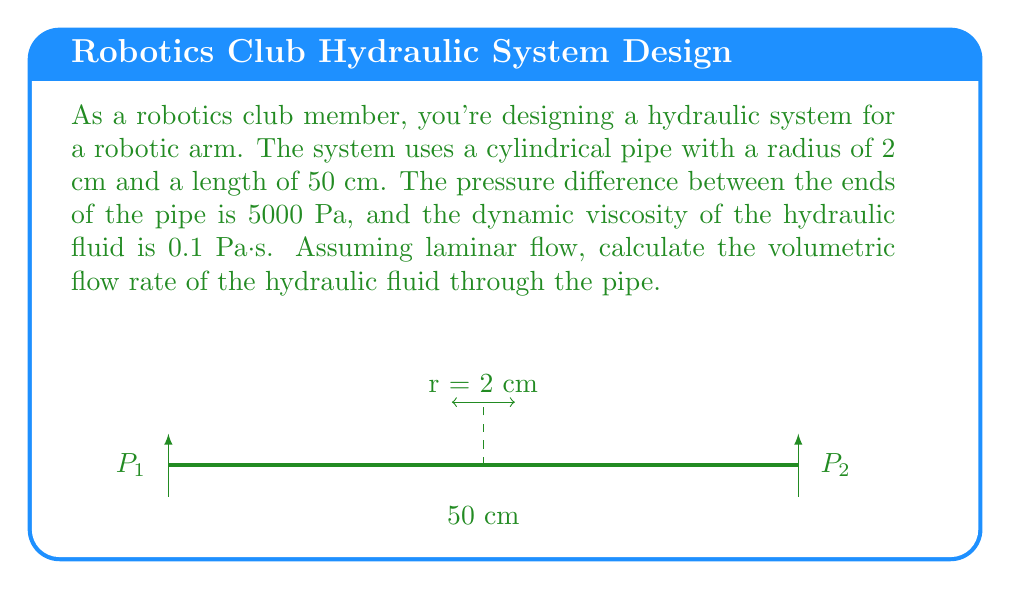Teach me how to tackle this problem. To solve this problem, we'll use the Hagen-Poiseuille equation, which is derived from the Navier-Stokes equations for laminar flow in a pipe:

$$Q = \frac{\pi r^4 \Delta P}{8 \mu L}$$

Where:
$Q$ = volumetric flow rate (m³/s)
$r$ = radius of the pipe (m)
$\Delta P$ = pressure difference (Pa)
$\mu$ = dynamic viscosity (Pa·s)
$L$ = length of the pipe (m)

Let's substitute the given values:

$r = 2 \text{ cm} = 0.02 \text{ m}$
$\Delta P = 5000 \text{ Pa}$
$\mu = 0.1 \text{ Pa·s}$
$L = 50 \text{ cm} = 0.5 \text{ m}$

Now, let's calculate:

$$\begin{aligned}
Q &= \frac{\pi (0.02 \text{ m})^4 \cdot 5000 \text{ Pa}}{8 \cdot 0.1 \text{ Pa·s} \cdot 0.5 \text{ m}} \\[10pt]
&= \frac{\pi \cdot 1.6 \times 10^{-7} \text{ m}^4 \cdot 5000 \text{ Pa}}{0.4 \text{ Pa·m}} \\[10pt]
&= \frac{2.513 \times 10^{-3} \text{ m}^4 \cdot \text{Pa}}{0.4 \text{ Pa·m}} \\[10pt]
&= 6.283 \times 10^{-3} \text{ m}^3/\text{s}
\end{aligned}$$

Converting to liters per minute:

$$6.283 \times 10^{-3} \text{ m}^3/\text{s} \cdot \frac{1000 \text{ L}}{1 \text{ m}^3} \cdot \frac{60 \text{ s}}{1 \text{ min}} = 376.98 \text{ L/min}$$
Answer: 377 L/min 